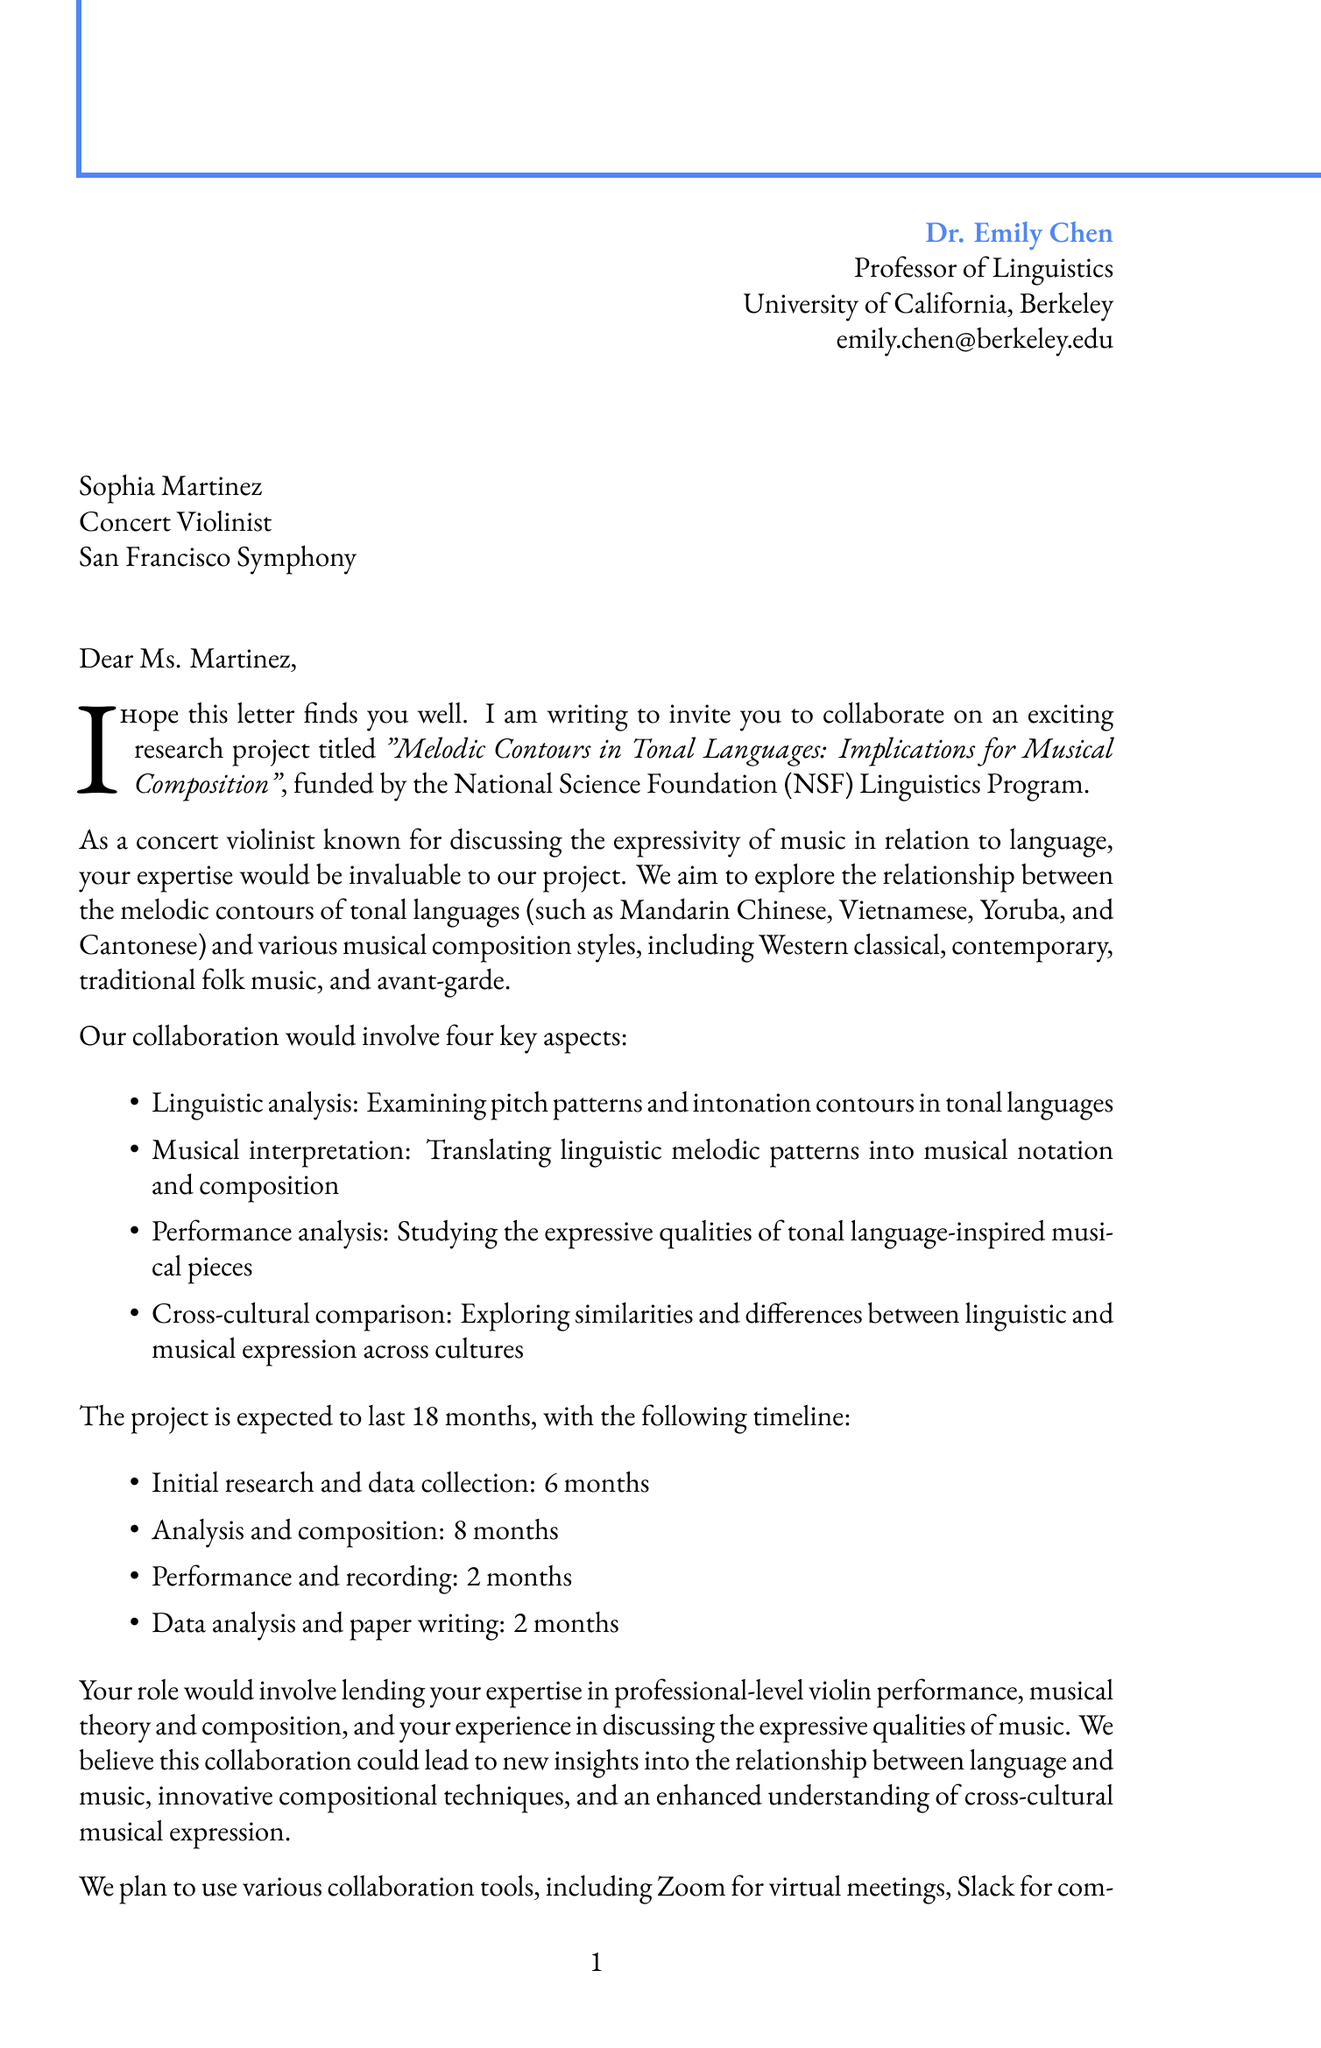what is the title of the research project? The title of the research project is explicitly stated in the document as "Melodic Contours in Tonal Languages: Implications for Musical Composition".
Answer: Melodic Contours in Tonal Languages: Implications for Musical Composition who is the sender of the letter? The sender's information is provided at the top of the letter, identifying Dr. Emily Chen as the sender.
Answer: Dr. Emily Chen how long is the project expected to last? The duration of the project is specified as 18 months in the document.
Answer: 18 months which funding source supports the project? The document mentions that the funding source for the project is the National Science Foundation (NSF) Linguistics Program.
Answer: National Science Foundation (NSF) Linguistics Program what are two tonal languages mentioned in the letter? The letter lists several tonal languages, among which Mandarin Chinese and Cantonese are mentioned.
Answer: Mandarin Chinese, Cantonese what is one aspect of collaboration described in the letter? The letter lists various aspects of collaboration, including "Linguistic analysis: Examining pitch patterns and intonation contours in tonal languages".
Answer: Linguistic analysis what is the proposed timeline's first phase? The document outlines the proposed timeline, with the first phase being "Initial research and data collection".
Answer: Initial research and data collection which tool is suggested for musical notation and composition? The letter specifies that Sibelius is to be used for music notation and composition during the collaboration.
Answer: Sibelius which conference is mentioned as a potential outcome for research presentation? The document lists several conferences, with the "International Conference on Music Perception and Cognition" mentioned as a potential outlet for research presentation.
Answer: International Conference on Music Perception and Cognition 